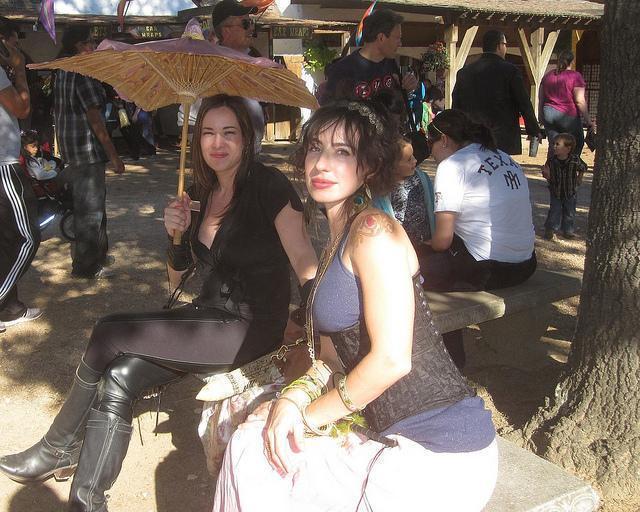The umbrella is made of what material?
Pick the correct solution from the four options below to address the question.
Options: Plastic, bamboo, denim, polyester. Bamboo. 